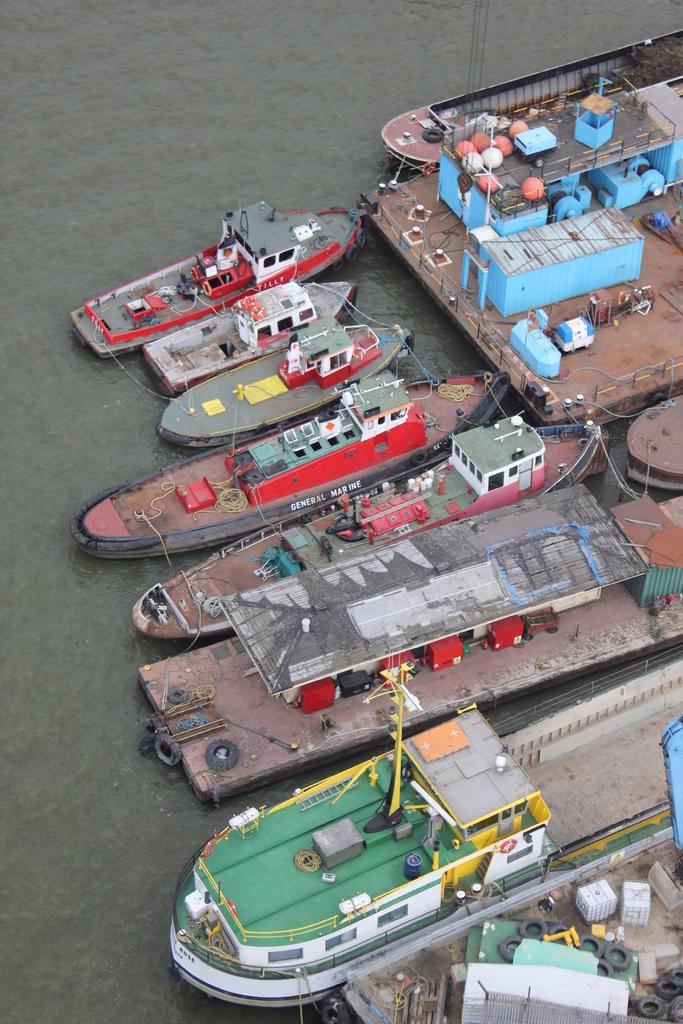Please provide a concise description of this image. The image is taken in a shipyard. In this picture there is a water body, in the water there are boats, ships, dock and other objects. 